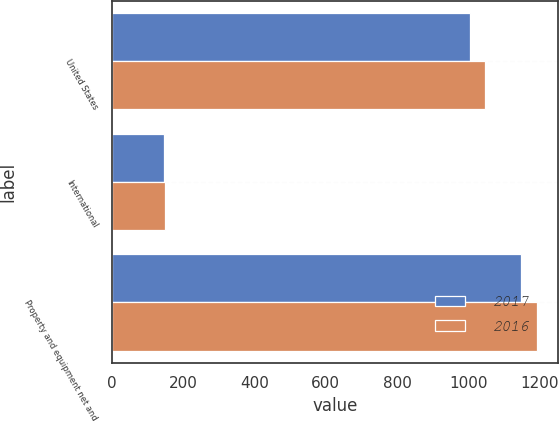<chart> <loc_0><loc_0><loc_500><loc_500><stacked_bar_chart><ecel><fcel>United States<fcel>International<fcel>Property and equipment net and<nl><fcel>2017<fcel>1005.1<fcel>144.1<fcel>1149.2<nl><fcel>2016<fcel>1046.6<fcel>147.4<fcel>1194<nl></chart> 